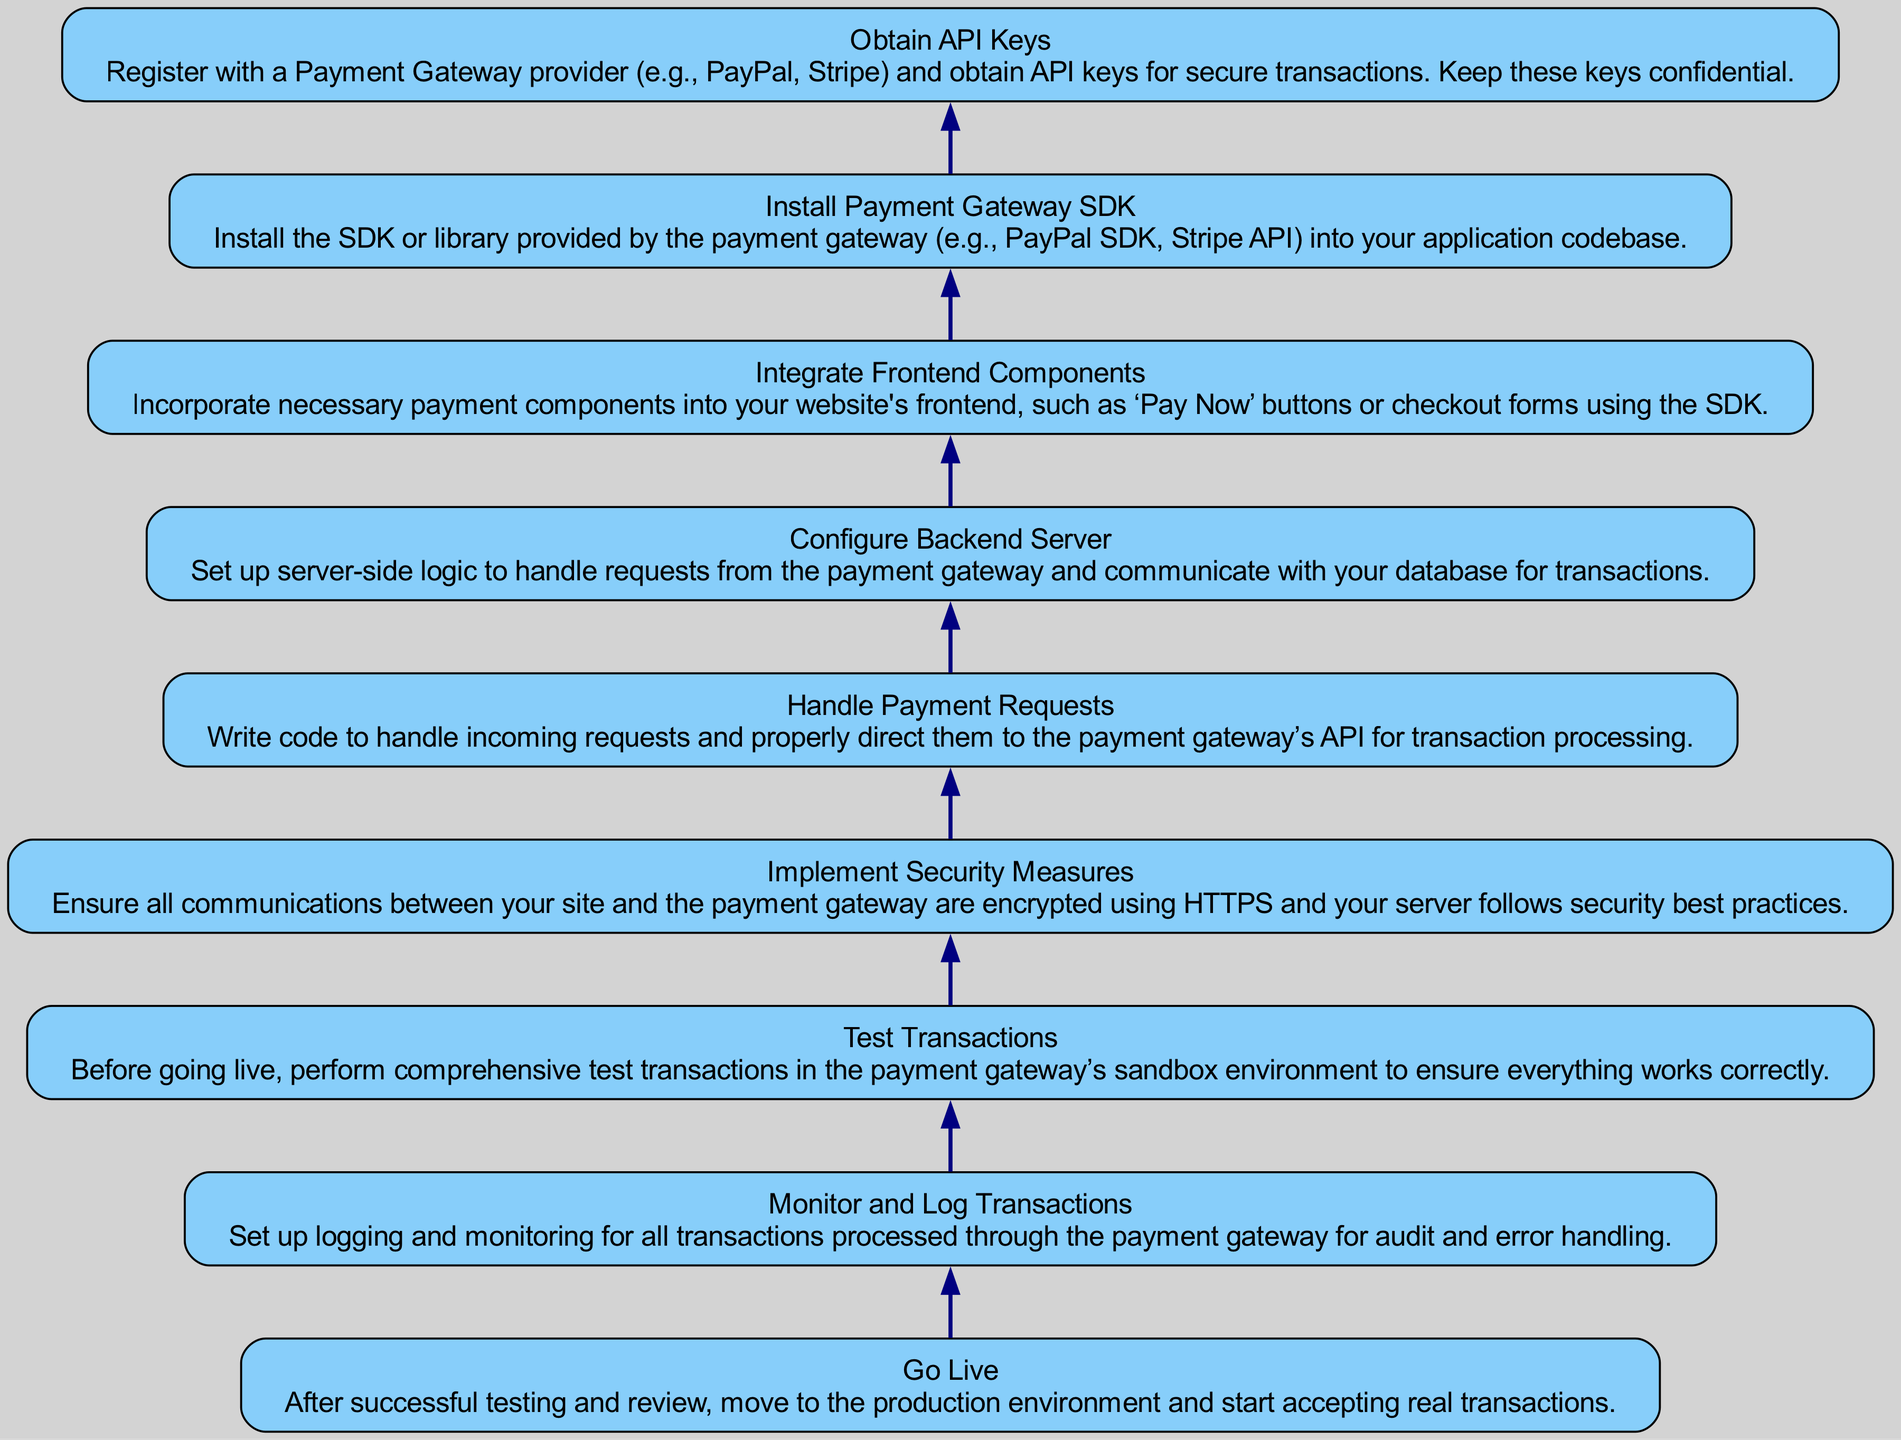What is the first step in the integration process? The diagram shows that the integration process starts with the step "Obtain API Keys". This is the bottom-most node and the first action required in the flow.
Answer: Obtain API Keys How many total steps are listed in the diagram? By counting the nodes represented in the diagram, there are a total of 9 steps listed (from "Obtain API Keys" to "Go Live").
Answer: 9 steps Which step comes immediately after "Handle Payment Requests"? In reviewing the flow, the step that follows "Handle Payment Requests" is "Implement Security Measures". The arrows indicate the direct connection indicating the order of execution.
Answer: Implement Security Measures What is the final step before going live in the transaction process? The final step in the process before going live is "Monitor and Log Transactions". This step is positioned just above "Go Live" in the flow, indicating its place in the sequence.
Answer: Monitor and Log Transactions What action should be performed before moving to the production environment? Before moving to a live environment, the required action is to "Test Transactions". It is directly indicated in the steps that testing should be completed prior to going live.
Answer: Test Transactions Which step involves configuring the backend server? The step that involves configuring the backend server is "Configure Backend Server". It deals with setting up the logic necessary to handle payment requests.
Answer: Configure Backend Server Where does "Integrate Frontend Components" fit in the flow? "Integrate Frontend Components" is positioned above "Install Payment Gateway SDK" and below "Obtain API Keys". This establishes its location within the sequence of actions to be taken.
Answer: Above Install Payment Gateway SDK What is emphasized in the "Implement Security Measures" step? The "Implement Security Measures" step emphasizes that all communications must be encrypted using HTTPS and that security best practices must be followed to protect transactions.
Answer: Encryption and best practices What precedes the transaction process in the flow? The action that precedes the transaction process is "Handle Payment Requests", which involves directing incoming requests to the payment gateway’s API. This is a pivotal step before any transactions take place.
Answer: Handle Payment Requests 